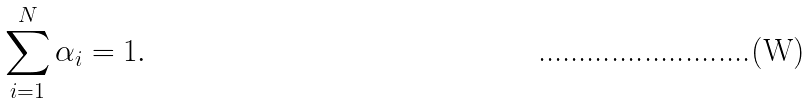Convert formula to latex. <formula><loc_0><loc_0><loc_500><loc_500>\sum _ { i = 1 } ^ { N } \alpha _ { i } = 1 .</formula> 